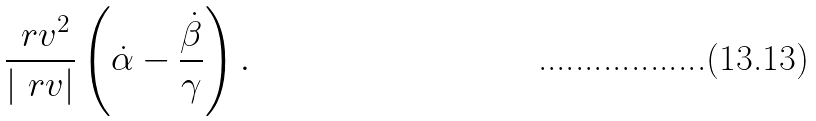Convert formula to latex. <formula><loc_0><loc_0><loc_500><loc_500>\frac { \ r v ^ { 2 } } { | \ r v | } \left ( \dot { \alpha } - \frac { \dot { \beta } } { \gamma } \right ) .</formula> 